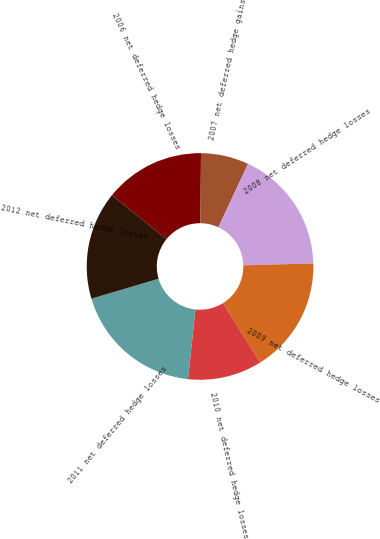Convert chart. <chart><loc_0><loc_0><loc_500><loc_500><pie_chart><fcel>2006 net deferred hedge losses<fcel>2007 net deferred hedge gains<fcel>2008 net deferred hedge losses<fcel>2009 net deferred hedge losses<fcel>2010 net deferred hedge losses<fcel>2011 net deferred hedge losses<fcel>2012 net deferred hedge losses<nl><fcel>14.31%<fcel>6.83%<fcel>17.61%<fcel>16.51%<fcel>10.61%<fcel>18.71%<fcel>15.41%<nl></chart> 